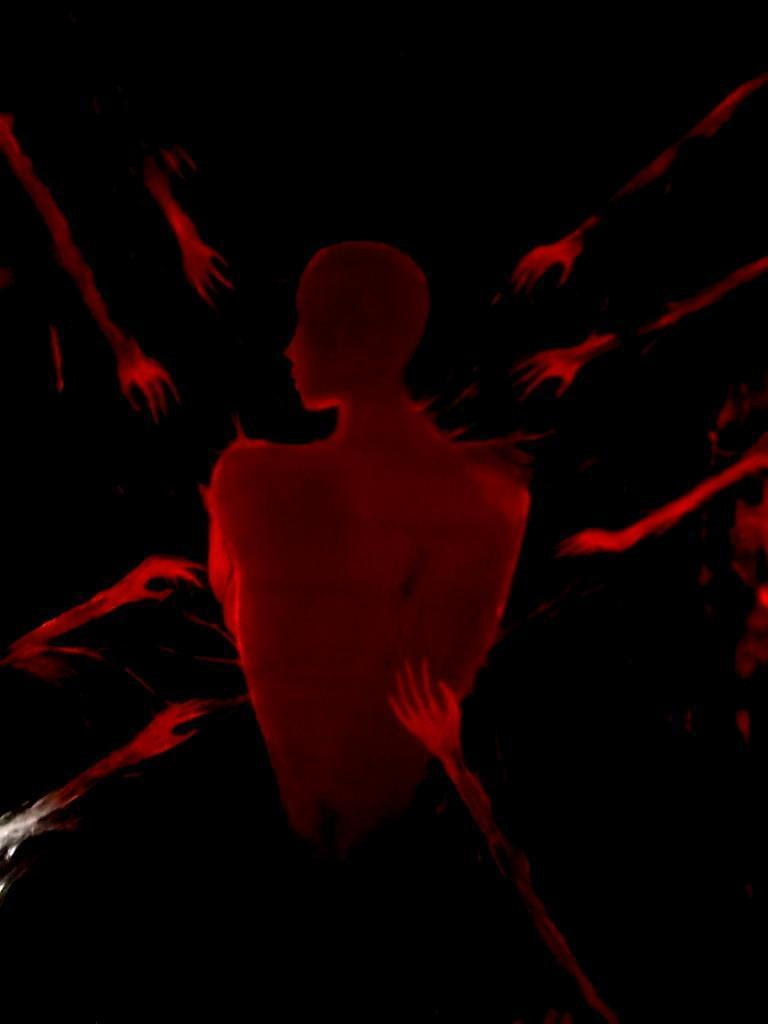What is the main subject of the painting? The painting depicts a person's face and half body. Are the person's hands visible in the painting? No, the person's hands are not visible in the painting. What color is the person's body in the painting? The person's body is painted in red color. What can be seen surrounding the person in the painting? There are hands surrounding the person in the painting. How would you describe the background of the painting? The background of the painting is dark. How many times has the person in the painting been on a flight? The painting does not provide any information about the person's flight history, as it only depicts their face and half body. What type of wound can be seen on the person's grandfather in the painting? There is no grandfather or wound present in the painting; it only depicts a person's face and half body. 